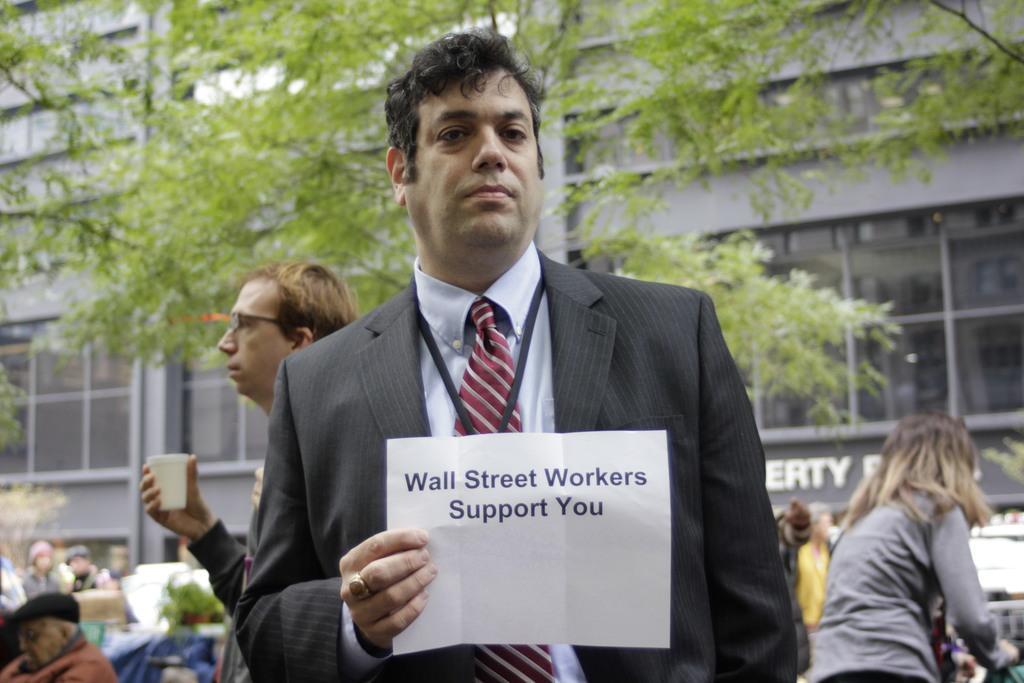Describe this image in one or two sentences. In the image we can see a man standing, wearing clothes, finger ring and holding a paper in hand. Behind him we can see there are many other people standing and some of them are sitting. Here we can see the building and the windows of the building. Here we can see the text and the trees. 